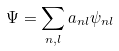<formula> <loc_0><loc_0><loc_500><loc_500>\Psi = \sum _ { n , l } a _ { n l } \psi _ { n l }</formula> 